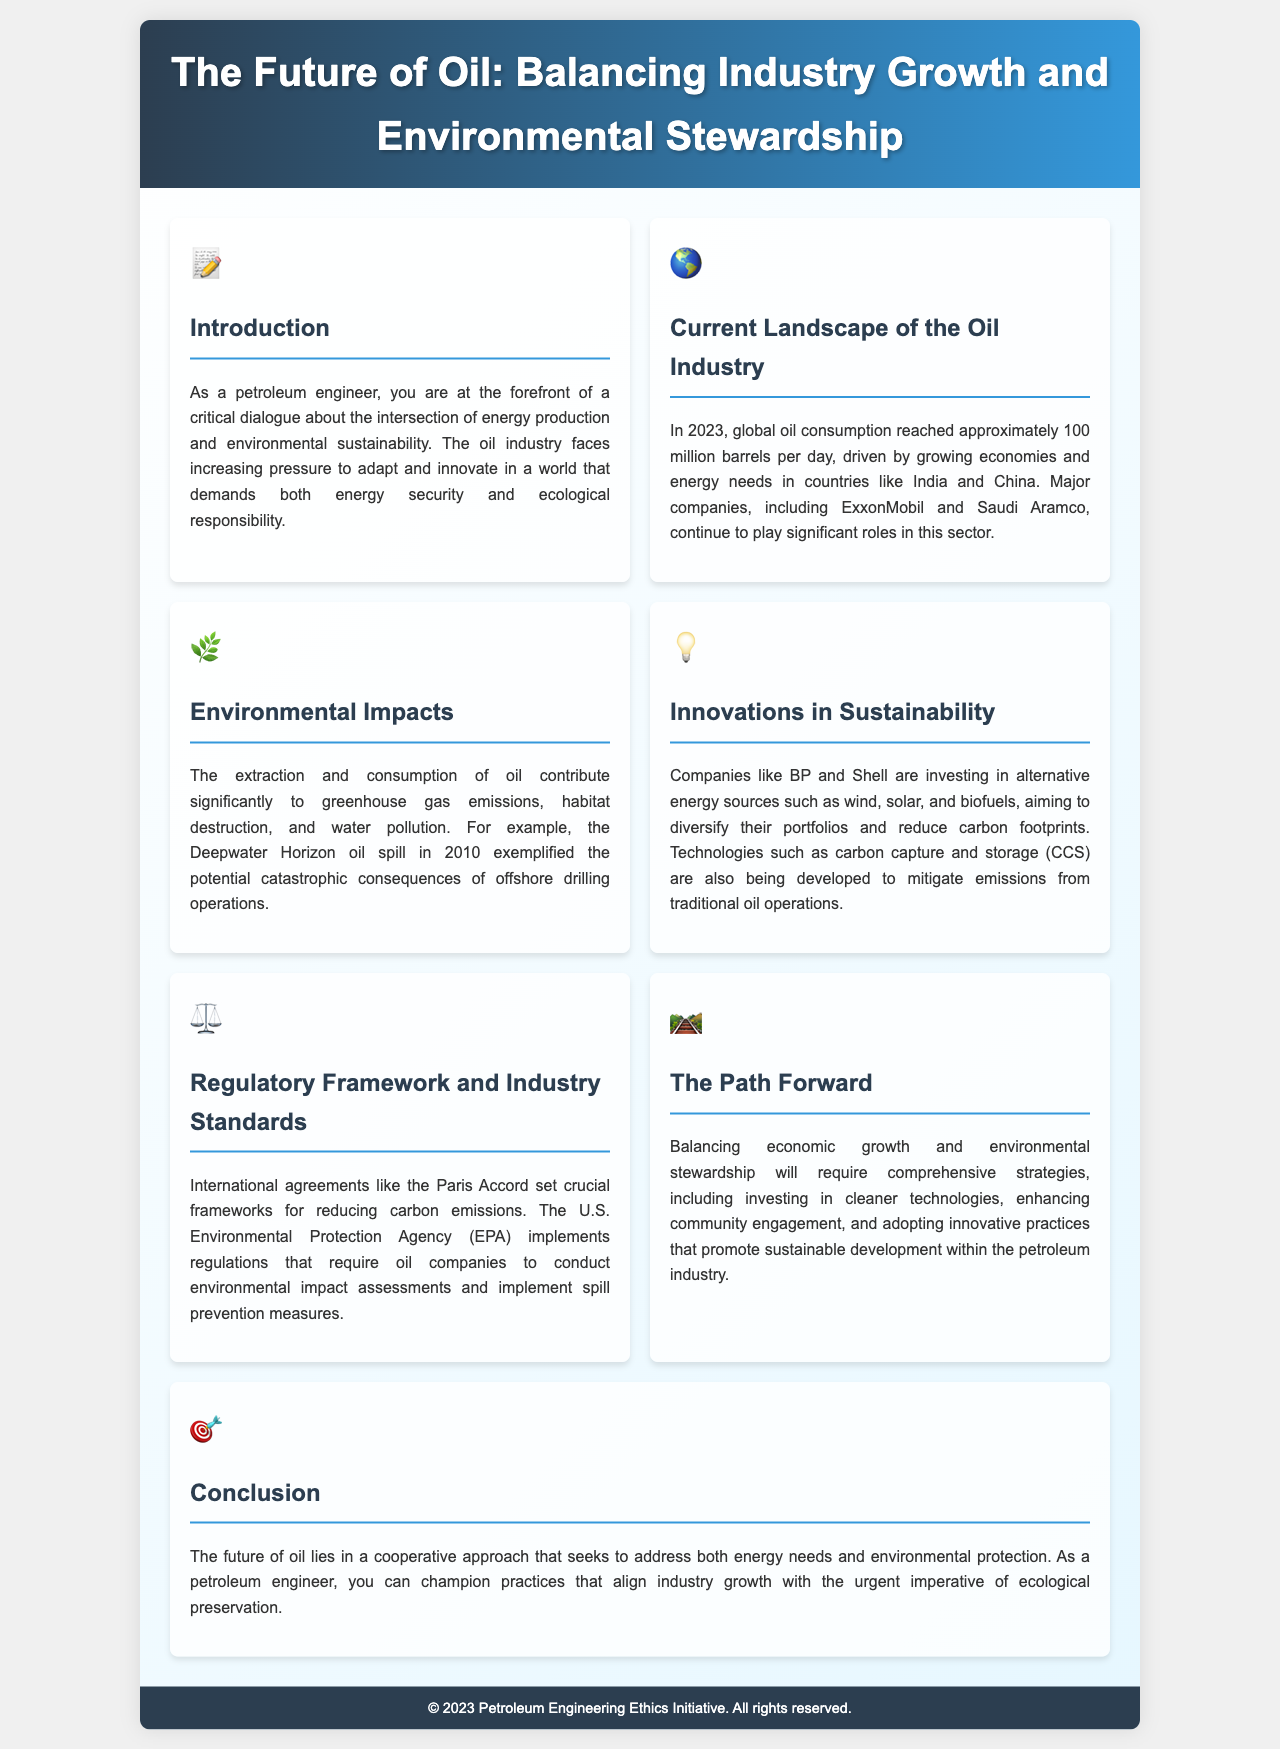what is the title of the brochure? The title is stated in the header of the document.
Answer: The Future of Oil: Balancing Industry Growth and Environmental Stewardship how many million barrels of oil were consumed globally in 2023? The document states the specific figure related to global oil consumption.
Answer: approximately 100 million barrels per day which company is mentioned in relation to sustainable energy investments? The section discusses companies that are investing in alternative energy sources.
Answer: BP and Shell what environmental disaster is referenced as an example? The document provides a specific incident as a notable example of environmental impacts.
Answer: Deepwater Horizon oil spill what type of technologies are being developed to mitigate emissions? The document mentions specific technologies related to emissions management.
Answer: carbon capture and storage (CCS) which regulatory agreement is mentioned in the context of carbon emissions? The text refers to a key international agreement concerning emissions reduction.
Answer: the Paris Accord what is emphasized as essential for balancing growth and stewardship? The document highlights a specific strategy for achieving balance between growth and environmental protection.
Answer: comprehensive strategies what role does the U.S. Environmental Protection Agency have? The brochure explains the responsibilities of a specific regulatory body regarding the oil industry.
Answer: implement regulations 